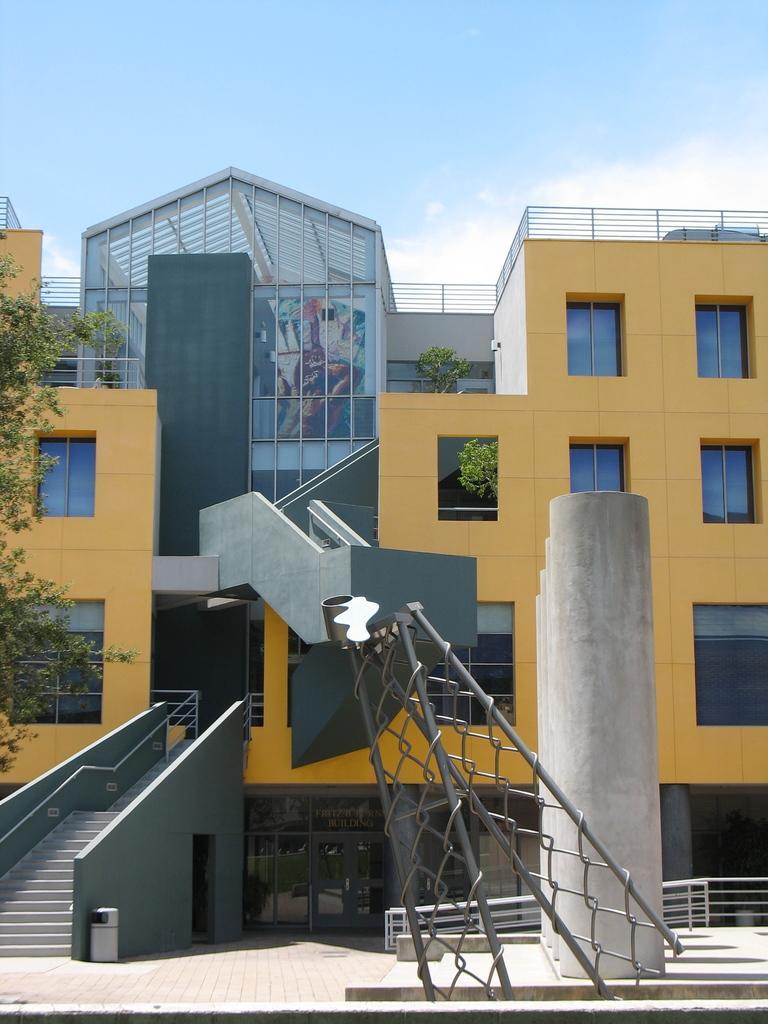In one or two sentences, can you explain what this image depicts? In this picture we can see a building, on the left side there is a tree and stairs, we can see mesh in the front, on the right side there is railing, we can see the sky at the top of the picture. 